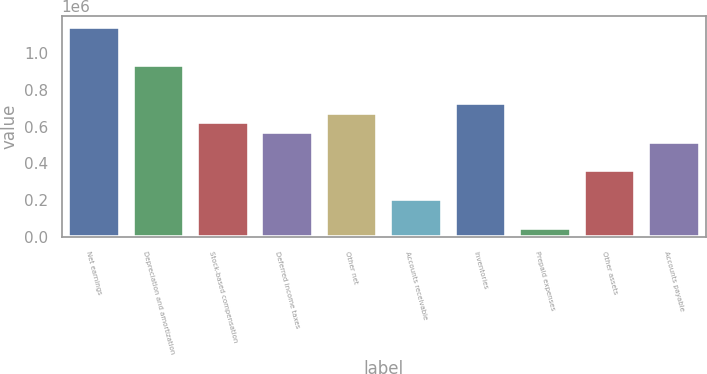Convert chart. <chart><loc_0><loc_0><loc_500><loc_500><bar_chart><fcel>Net earnings<fcel>Depreciation and amortization<fcel>Stock-based compensation<fcel>Deferred income taxes<fcel>Other net<fcel>Accounts receivable<fcel>Inventories<fcel>Prepaid expenses<fcel>Other assets<fcel>Accounts payable<nl><fcel>1.14198e+06<fcel>934348<fcel>622905<fcel>570997<fcel>674812<fcel>207646<fcel>726719<fcel>51924.3<fcel>363368<fcel>519090<nl></chart> 